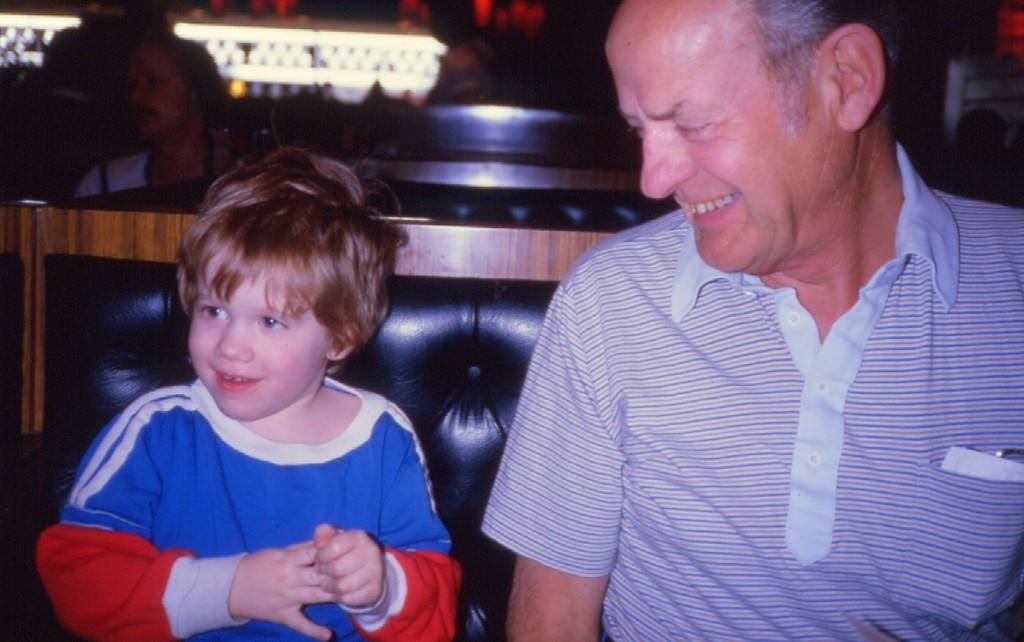Who is present in the image? There is a man and a boy in the image. What are they doing in the image? Both the man and the boy are sitting on a sofa. What is the emotional expression of the man and the boy? The man and the boy are smiling in the image. Can you describe the background of the image? There are people and lights visible in the background of the image, and the background is dark. What type of steel is used to construct the sofa in the image? There is no information about the material used to construct the sofa in the image. --- Facts: 1. There is a car in the image. 2. The car is red. 3. The car has four wheels. 4. There are people visible in the background of the image. 5. The background of the image is a cityscape. Absurd Topics: dance, ocean, instrument Conversation: What is the main subject of the image? The main subject of the image is a car. What color is the car? The car is red. How many wheels does the car have? The car has four wheels. Can you describe the background of the image? There are people visible in the background of the image, and the background is a cityscape. Reasoning: Let's think step by step in order to produce the conversation. We start by identifying the main subject in the image, which is the car. Then, we describe its color and the number of wheels it has. Next, we expand the conversation to include details about the background, such as the presence of people and the cityscape. Each question is designed to elicit a specific detail about the image that is known from the provided facts. Absurd Question/Answer: What type of dance is being performed by the ocean in the image? There is no ocean or dance present in the image; it features a red car with four wheels and a cityscape background. --- Facts: 1. There is a dog in the image. 2. The dog is brown. 3. The dog is sitting on a rug. 4. There is a toy in the image. 5. The toy is a ball. Absurd Topics: swim, mountain, book Conversation: What is the main subject of the image? The main subject of the image is a dog. What color is the dog? The dog is brown. What is the dog sitting on? The dog is sitting on a rug. Can you describe any other objects in the image? There is a toy in the image, which is a ball. Reasoning: Let's think step by step in order to produce the conversation. We start by identifying the main subject in the image, which is the dog. Then, we describe its color and the 